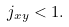Convert formula to latex. <formula><loc_0><loc_0><loc_500><loc_500>j _ { x y } < 1 .</formula> 